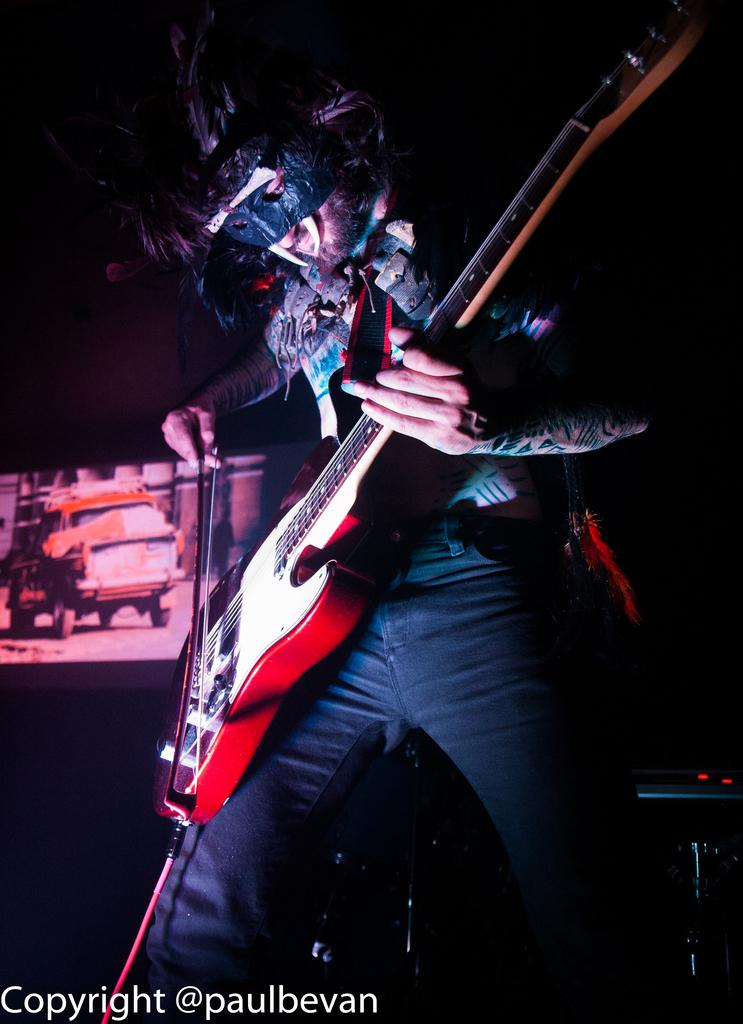What is the person in the image doing? The person is standing in the image and holding a guitar. What object is the person holding in the image? The person is holding a guitar. What can be seen in the background of the image? There is a screen visible in the background of the image. What type of crayon is the person using to draw on the screen in the image? There is no crayon or drawing activity present in the image; the person is holding a guitar and standing in front of a screen. 